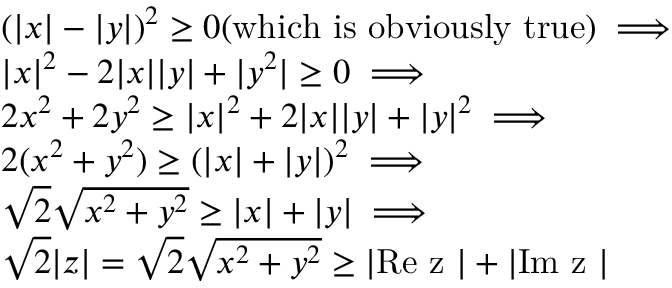Convert formula to latex. <formula><loc_0><loc_0><loc_500><loc_500>\begin{array} { r l } & { \left ( | x | - | y | \right ) ^ { 2 } \geq 0 ( w h i c h i s o b v i o u s l y t r u e ) \implies } \\ & { | x | ^ { 2 } - 2 | x | | y | + | y ^ { 2 } | \geq 0 \implies } \\ & { 2 x ^ { 2 } + 2 y ^ { 2 } \geq | x | ^ { 2 } + 2 | x | | y | + | y | ^ { 2 } \implies } \\ & { 2 ( x ^ { 2 } + y ^ { 2 } ) \geq \left ( | x | + | y | \right ) ^ { 2 } \implies } \\ & { \sqrt { 2 } \sqrt { x ^ { 2 } + y ^ { 2 } } \geq | x | + | y | \implies } \\ & { \sqrt { 2 } | z | = \sqrt { 2 } \sqrt { x ^ { 2 } + y ^ { 2 } } \geq | R e z | + | I m z | } \end{array}</formula> 